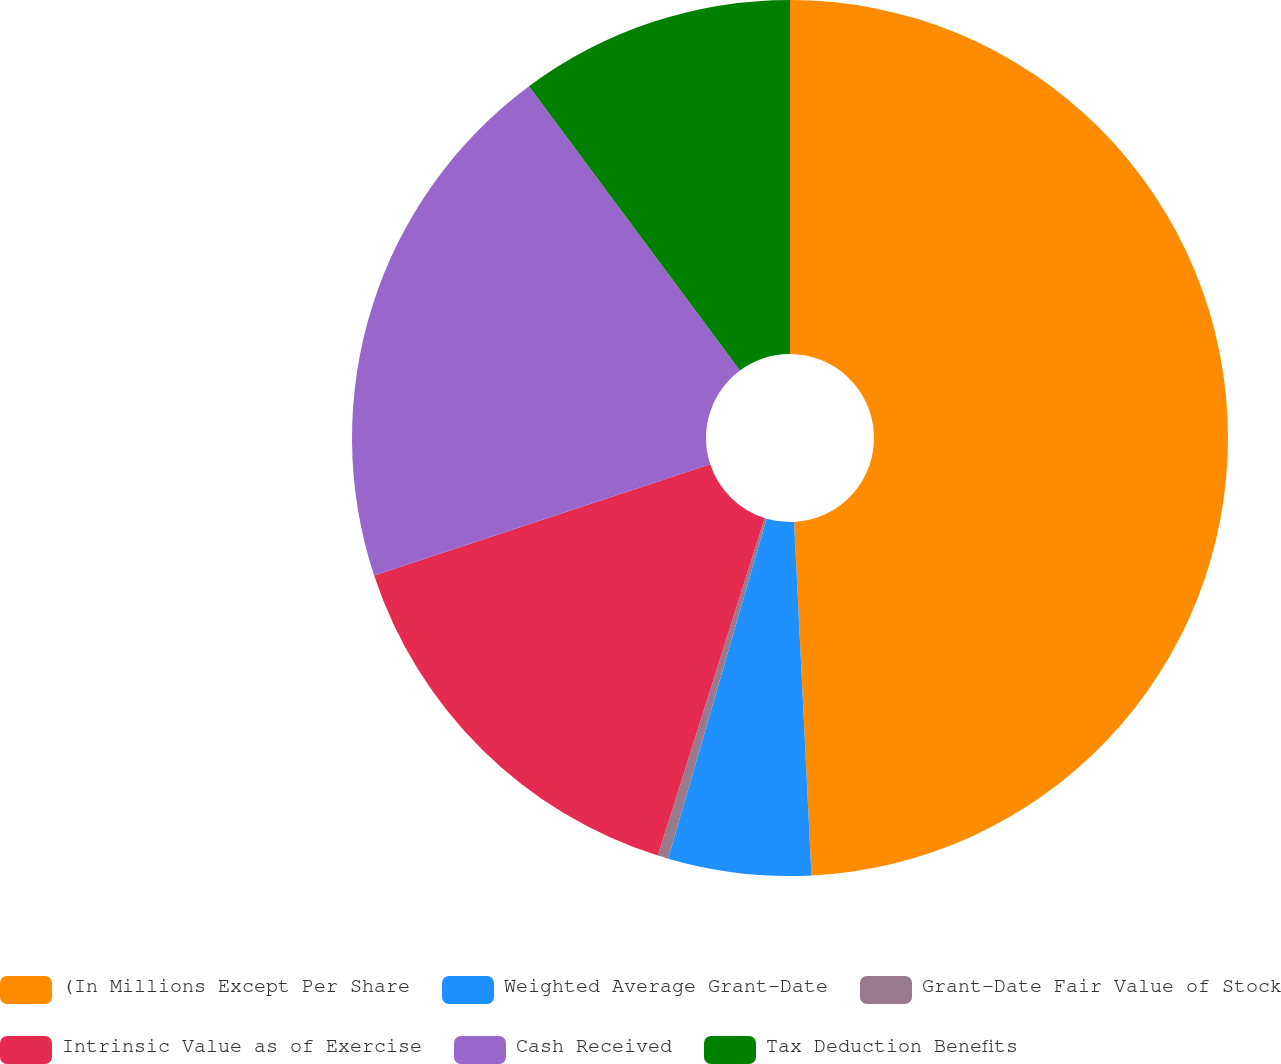<chart> <loc_0><loc_0><loc_500><loc_500><pie_chart><fcel>(In Millions Except Per Share<fcel>Weighted Average Grant-Date<fcel>Grant-Date Fair Value of Stock<fcel>Intrinsic Value as of Exercise<fcel>Cash Received<fcel>Tax Deduction Benefits<nl><fcel>49.22%<fcel>5.27%<fcel>0.39%<fcel>15.04%<fcel>19.92%<fcel>10.16%<nl></chart> 